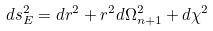Convert formula to latex. <formula><loc_0><loc_0><loc_500><loc_500>d s ^ { 2 } _ { E } = d r ^ { 2 } + r ^ { 2 } d \Omega _ { n + 1 } ^ { 2 } + d \chi ^ { 2 }</formula> 